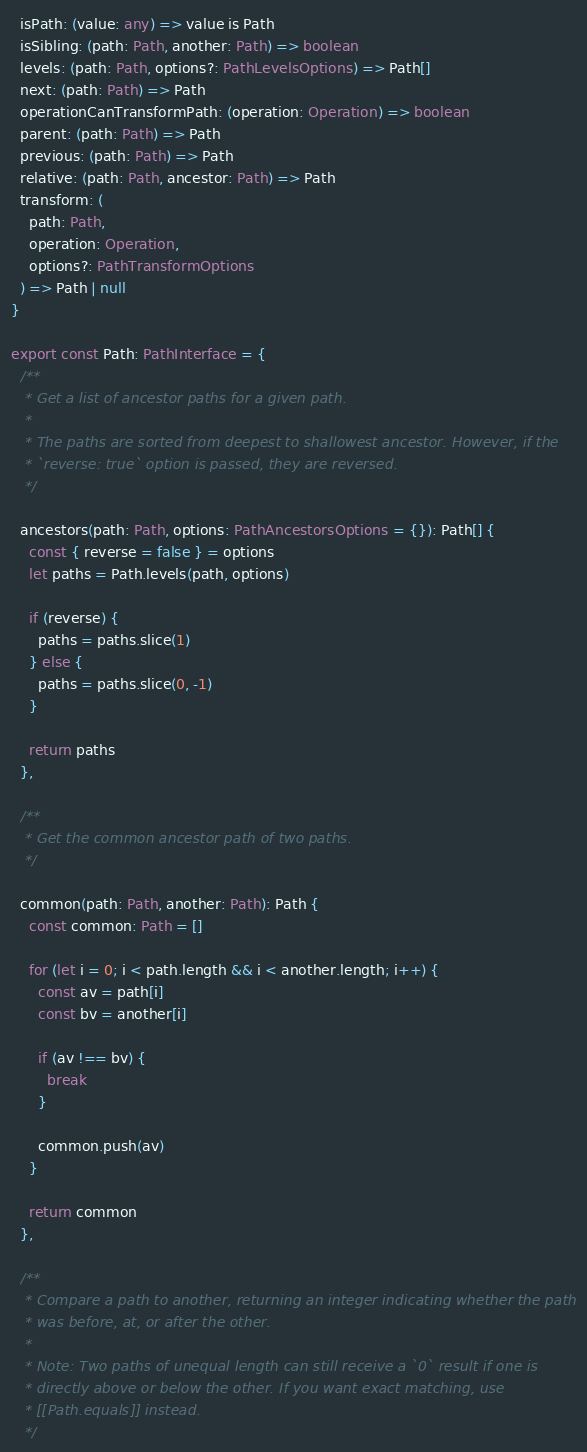<code> <loc_0><loc_0><loc_500><loc_500><_TypeScript_>  isPath: (value: any) => value is Path
  isSibling: (path: Path, another: Path) => boolean
  levels: (path: Path, options?: PathLevelsOptions) => Path[]
  next: (path: Path) => Path
  operationCanTransformPath: (operation: Operation) => boolean
  parent: (path: Path) => Path
  previous: (path: Path) => Path
  relative: (path: Path, ancestor: Path) => Path
  transform: (
    path: Path,
    operation: Operation,
    options?: PathTransformOptions
  ) => Path | null
}

export const Path: PathInterface = {
  /**
   * Get a list of ancestor paths for a given path.
   *
   * The paths are sorted from deepest to shallowest ancestor. However, if the
   * `reverse: true` option is passed, they are reversed.
   */

  ancestors(path: Path, options: PathAncestorsOptions = {}): Path[] {
    const { reverse = false } = options
    let paths = Path.levels(path, options)

    if (reverse) {
      paths = paths.slice(1)
    } else {
      paths = paths.slice(0, -1)
    }

    return paths
  },

  /**
   * Get the common ancestor path of two paths.
   */

  common(path: Path, another: Path): Path {
    const common: Path = []

    for (let i = 0; i < path.length && i < another.length; i++) {
      const av = path[i]
      const bv = another[i]

      if (av !== bv) {
        break
      }

      common.push(av)
    }

    return common
  },

  /**
   * Compare a path to another, returning an integer indicating whether the path
   * was before, at, or after the other.
   *
   * Note: Two paths of unequal length can still receive a `0` result if one is
   * directly above or below the other. If you want exact matching, use
   * [[Path.equals]] instead.
   */
</code> 